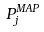<formula> <loc_0><loc_0><loc_500><loc_500>P _ { j } ^ { M A P }</formula> 